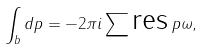<formula> <loc_0><loc_0><loc_500><loc_500>\int _ { b } d p = - 2 \pi i \sum \text {res} \, p \omega ,</formula> 